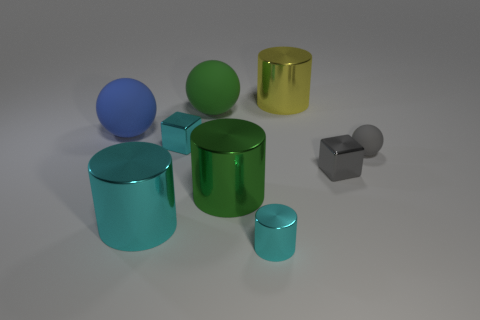Subtract all green cylinders. How many cylinders are left? 3 Subtract all tiny metallic cylinders. How many cylinders are left? 3 Add 1 blue matte objects. How many objects exist? 10 Subtract all gray cylinders. Subtract all gray balls. How many cylinders are left? 4 Subtract all cylinders. How many objects are left? 5 Subtract all small gray metallic cylinders. Subtract all green balls. How many objects are left? 8 Add 2 big green rubber things. How many big green rubber things are left? 3 Add 2 big cyan shiny objects. How many big cyan shiny objects exist? 3 Subtract 0 yellow blocks. How many objects are left? 9 